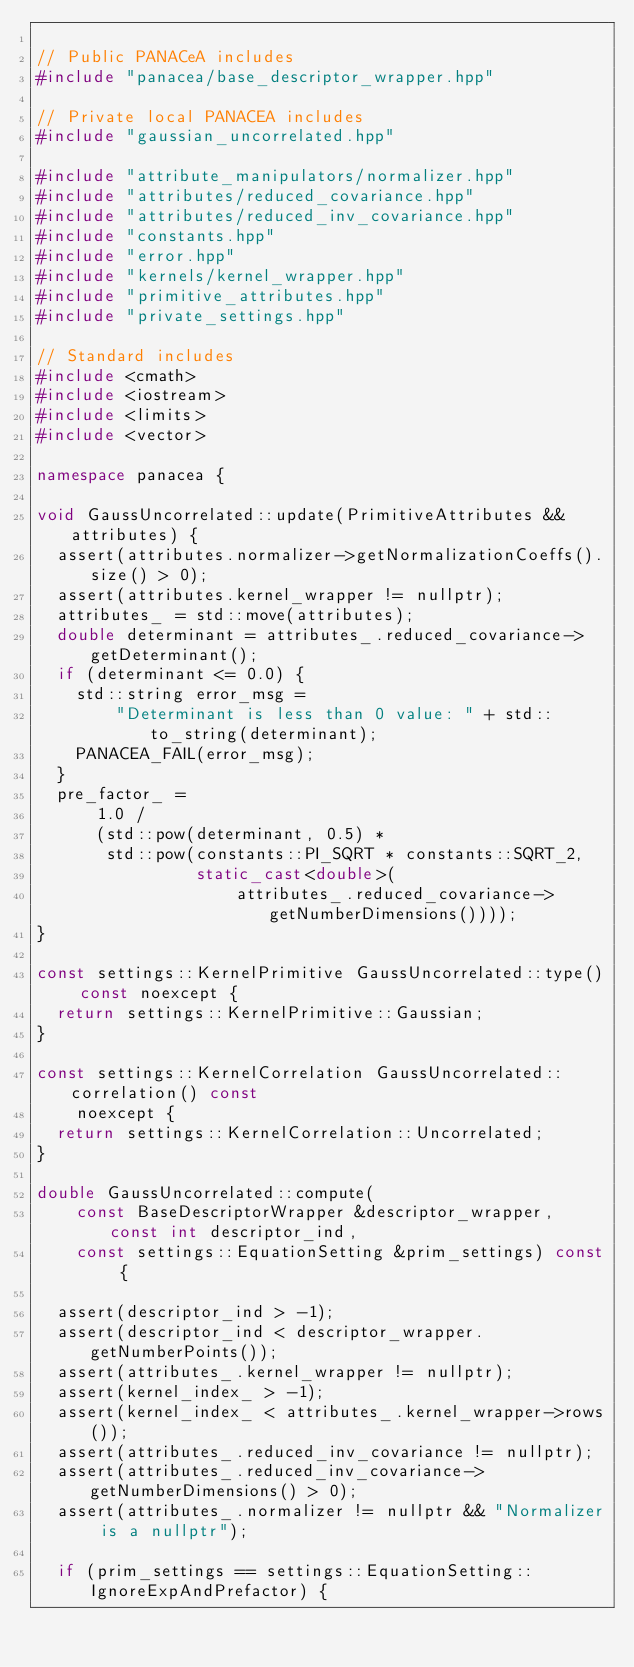<code> <loc_0><loc_0><loc_500><loc_500><_C++_>
// Public PANACeA includes
#include "panacea/base_descriptor_wrapper.hpp"

// Private local PANACEA includes
#include "gaussian_uncorrelated.hpp"

#include "attribute_manipulators/normalizer.hpp"
#include "attributes/reduced_covariance.hpp"
#include "attributes/reduced_inv_covariance.hpp"
#include "constants.hpp"
#include "error.hpp"
#include "kernels/kernel_wrapper.hpp"
#include "primitive_attributes.hpp"
#include "private_settings.hpp"

// Standard includes
#include <cmath>
#include <iostream>
#include <limits>
#include <vector>

namespace panacea {

void GaussUncorrelated::update(PrimitiveAttributes &&attributes) {
  assert(attributes.normalizer->getNormalizationCoeffs().size() > 0);
  assert(attributes.kernel_wrapper != nullptr);
  attributes_ = std::move(attributes);
  double determinant = attributes_.reduced_covariance->getDeterminant();
  if (determinant <= 0.0) {
    std::string error_msg =
        "Determinant is less than 0 value: " + std::to_string(determinant);
    PANACEA_FAIL(error_msg);
  }
  pre_factor_ =
      1.0 /
      (std::pow(determinant, 0.5) *
       std::pow(constants::PI_SQRT * constants::SQRT_2,
                static_cast<double>(
                    attributes_.reduced_covariance->getNumberDimensions())));
}

const settings::KernelPrimitive GaussUncorrelated::type() const noexcept {
  return settings::KernelPrimitive::Gaussian;
}

const settings::KernelCorrelation GaussUncorrelated::correlation() const
    noexcept {
  return settings::KernelCorrelation::Uncorrelated;
}

double GaussUncorrelated::compute(
    const BaseDescriptorWrapper &descriptor_wrapper, const int descriptor_ind,
    const settings::EquationSetting &prim_settings) const {

  assert(descriptor_ind > -1);
  assert(descriptor_ind < descriptor_wrapper.getNumberPoints());
  assert(attributes_.kernel_wrapper != nullptr);
  assert(kernel_index_ > -1);
  assert(kernel_index_ < attributes_.kernel_wrapper->rows());
  assert(attributes_.reduced_inv_covariance != nullptr);
  assert(attributes_.reduced_inv_covariance->getNumberDimensions() > 0);
  assert(attributes_.normalizer != nullptr && "Normalizer is a nullptr");

  if (prim_settings == settings::EquationSetting::IgnoreExpAndPrefactor) {</code> 